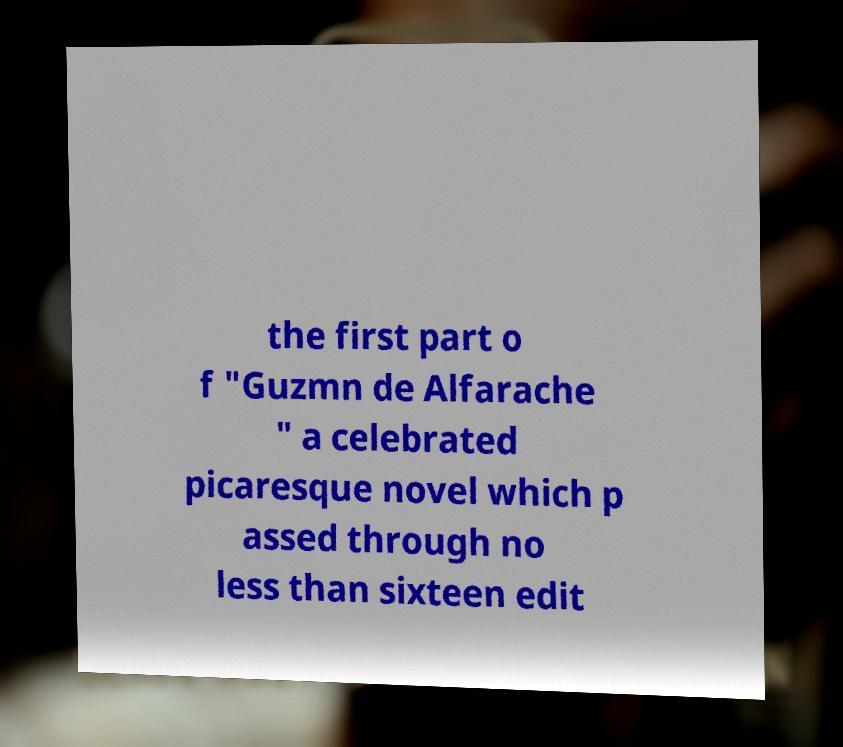I need the written content from this picture converted into text. Can you do that? the first part o f "Guzmn de Alfarache " a celebrated picaresque novel which p assed through no less than sixteen edit 